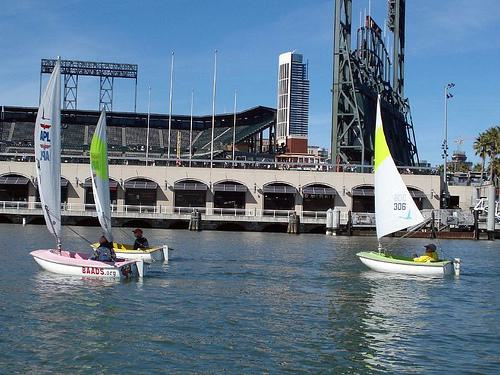Is there a boat in the image? Yes 